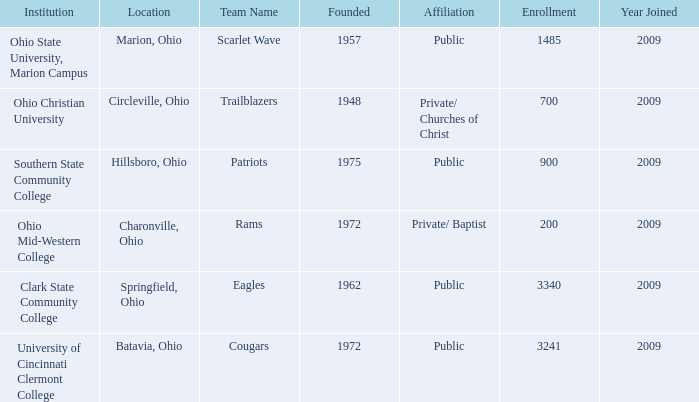What is the location for the team name of eagles? Springfield, Ohio. 